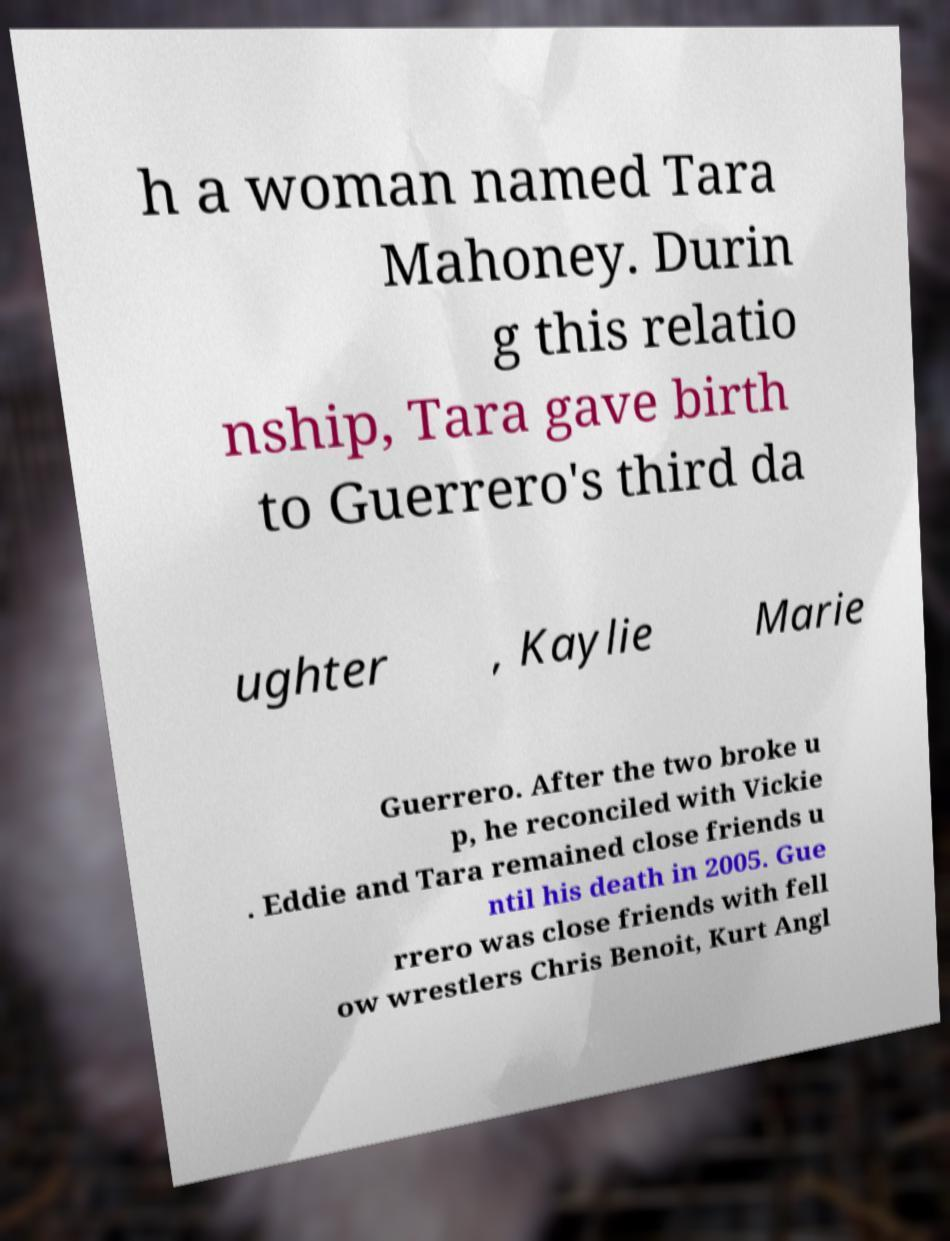Could you assist in decoding the text presented in this image and type it out clearly? h a woman named Tara Mahoney. Durin g this relatio nship, Tara gave birth to Guerrero's third da ughter , Kaylie Marie Guerrero. After the two broke u p, he reconciled with Vickie . Eddie and Tara remained close friends u ntil his death in 2005. Gue rrero was close friends with fell ow wrestlers Chris Benoit, Kurt Angl 